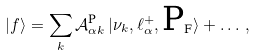<formula> <loc_0><loc_0><loc_500><loc_500>| f \rangle = \sum _ { k } \mathcal { A } ^ { \text {P} } _ { \alpha k } \, | \nu _ { k } , \ell _ { \alpha } ^ { + } , \text {P} _ { \text {F} } \rangle + \dots \, ,</formula> 